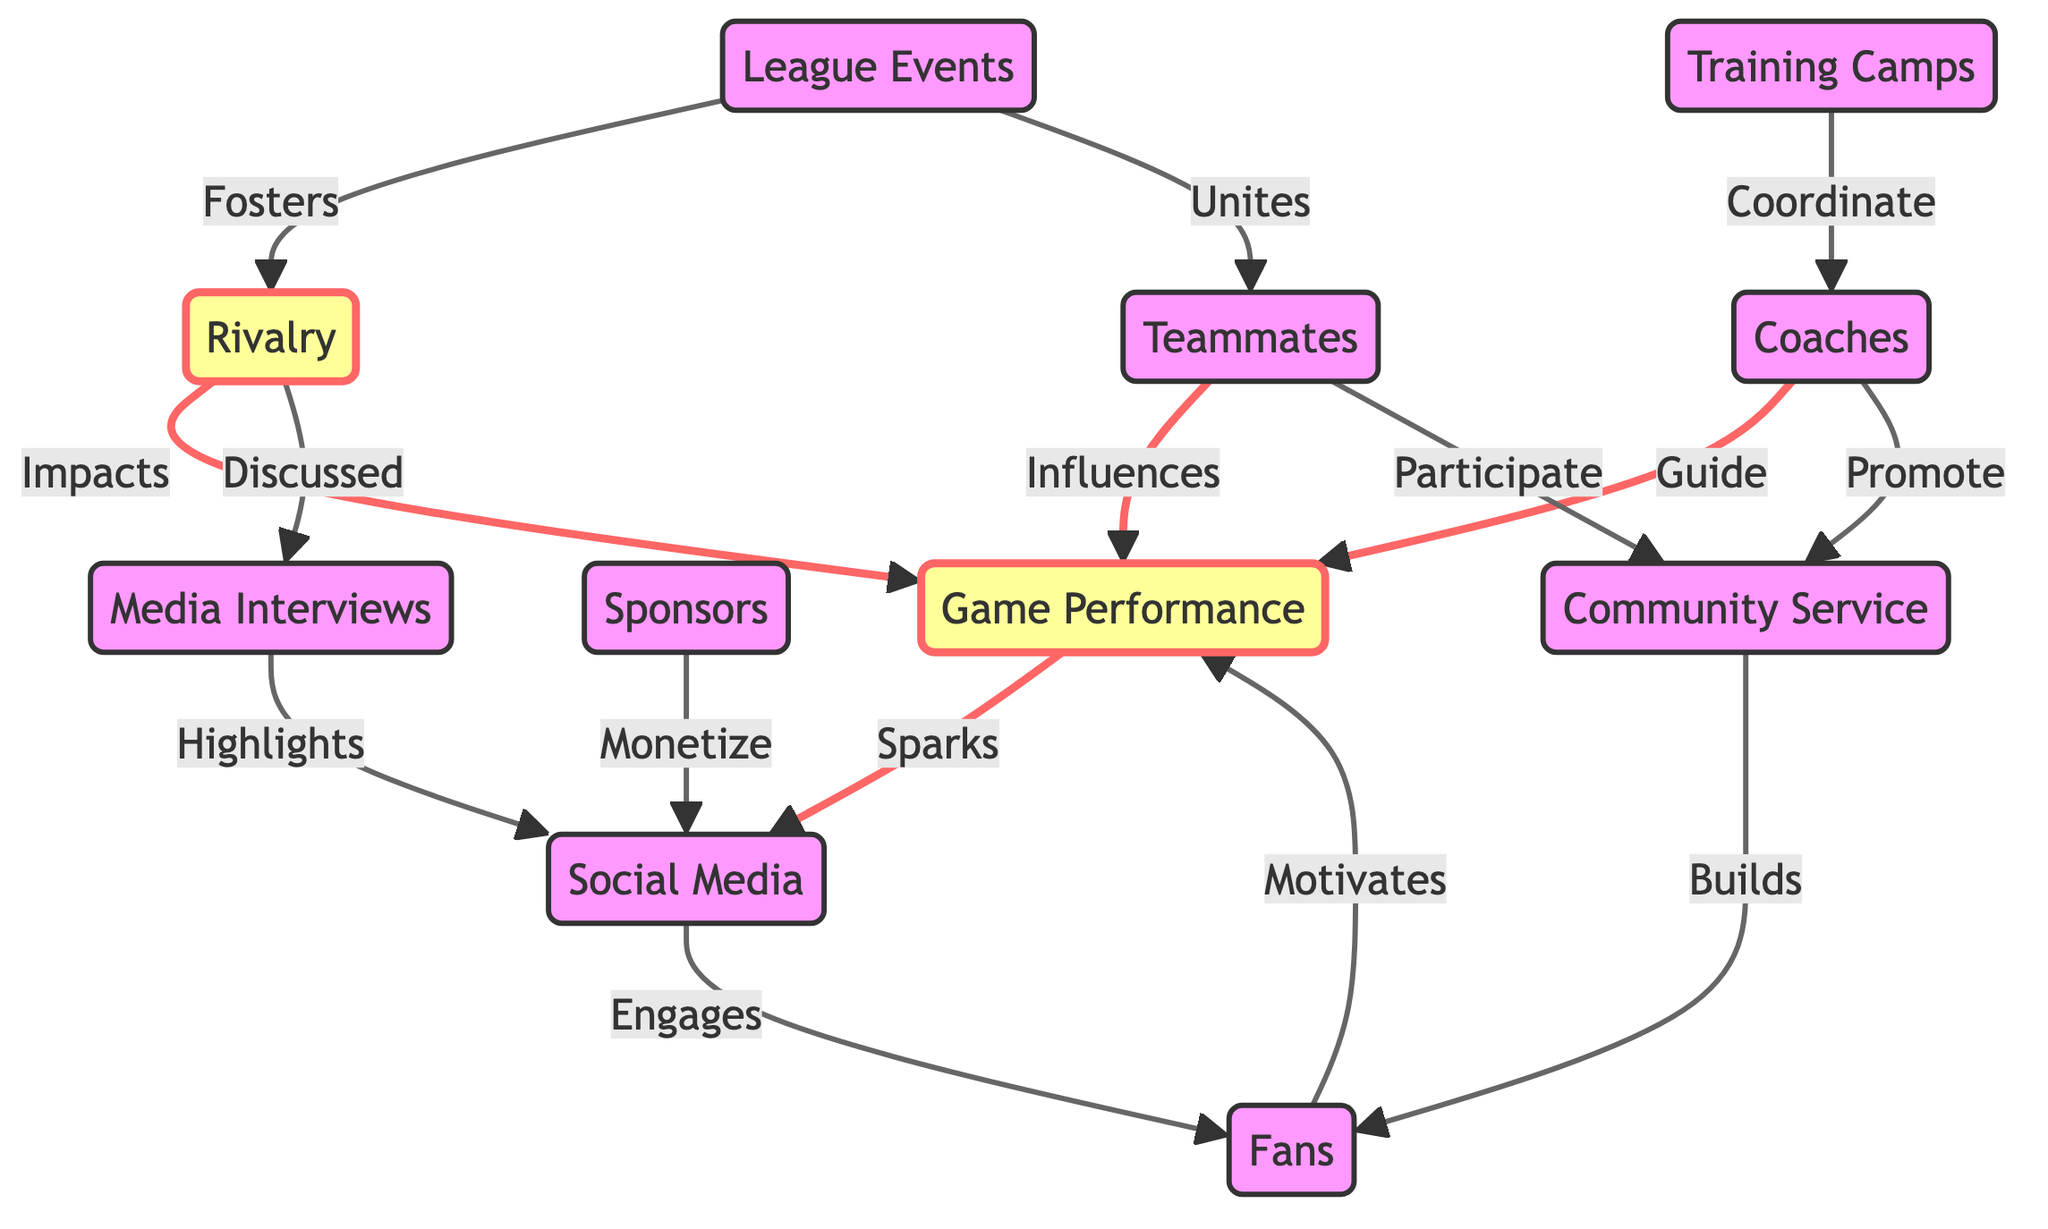What is the total number of nodes in the diagram? The diagram includes 10 nodes representing various aspects of networking and relationship building in the PBA League. The nodes are: rivalry, game performance, teammates, coaches, social media, sponsors, league events, fans, community service, and media interviews. Therefore, counting these gives us a total of 10.
Answer: 10 Which node is directly influenced by coaches? In the diagram, the edge from coaches to game performance indicates that coaches guide game performance. This direct influence shows the relationship between the coaches and the game performance node.
Answer: Game Performance How many edges are there in total? By examining the connections, the diagram indicates that there are 14 edges. Each edge represents a relationship or influence between two nodes, so all connections lead us to count them, resulting in a total of 14 edges.
Answer: 14 What effect does rivalry have on media interviews? The diagram shows an edge labeled "Discussed" pointing from rivalry to media interviews, indicating that rivalry is discussed in the context of media interviews. This reflects how rivalry contributes to the content shared in media interviews.
Answer: Discussed How do sponsors engage with social media? The connection from sponsors to social media labeled as "Monetize" illustrates that sponsors engage with social media by monetizing their presence. This relationship indicates a financial interaction, where sponsors utilize social media platforms for promotional activities.
Answer: Monetize What relationship do fans have with game performance? The diagram depicts an edge labeled "Motivates" from fans to game performance, signifying that fans motivate players' performance in games. This captures the influence of fan support on players' on-court actions and results.
Answer: Motivates Which nodes are directly influenced by league events? League events influence rivalry and unite teammates, as indicated by two edges leading from league events: one labeled "Fosters" to rivalry and another labeled "Unites" to teammates. This shows the dual role of league events in promoting both competitive relationships and camaraderie among players.
Answer: Rivalry, Teammates What does community service build in the context of fans? The diagram specifies a relationship from community service to fans labeled "Builds," indicating that community service initiatives contribute to building relationships or support from fans. This suggests that engaging in community service has a positive effect on fan loyalty and connection.
Answer: Builds Which node sparks social media engagement? The edge labeled "Sparks" from game performance to social media illustrates that game performance is a driving factor for engagement on social media platforms. This implies that significant performances in games often lead to increased social media activity surrounding players and teams.
Answer: Sparks 